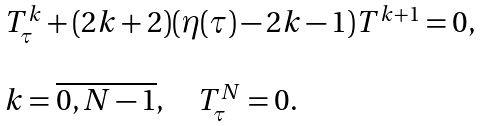<formula> <loc_0><loc_0><loc_500><loc_500>\begin{array} { l } T ^ { k } _ { \tau } + ( 2 k + 2 ) ( \eta ( \tau ) - 2 k - 1 ) T ^ { k + 1 } = 0 , \\ \\ k = \overline { 0 , N - 1 } , \quad T ^ { N } _ { \tau } = 0 . \end{array}</formula> 